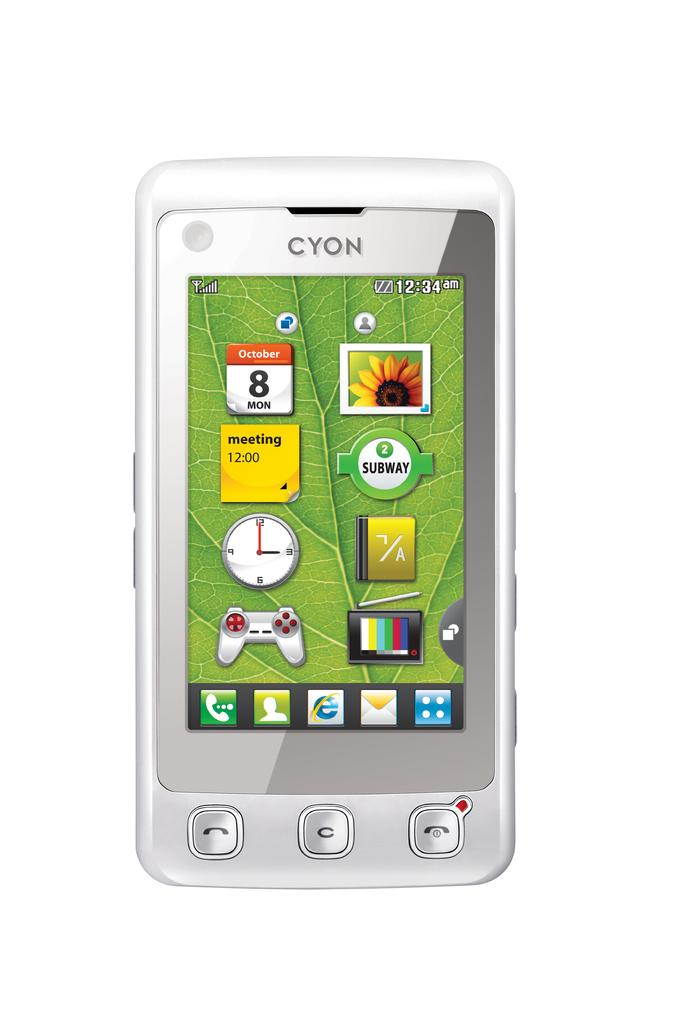<image>
Create a compact narrative representing the image presented. A Cyon cell phone with icons for various things. 